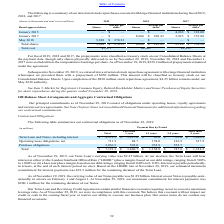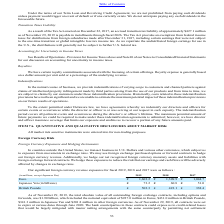According to Adobe Systems's financial document, What is the estimated maximum commitment for interest payments for the remaining duration of the Term Loan based on the LIBOR rate? According to the financial document, $23.2 million. The relevant text states: "mated maximum commitment for interest payments was $23.2 million for the remaining duration of the Term Loan...." Also, can you calculate: What portion of term loan and notes, including interest have payment due more than 5 years? Based on the calculation: 1,016.3/4,373.3 , the result is 23.24 (percentage). This is based on the information: "ding interest $ 4,373.3 $ 3,227.0 $ 65.0 $ 65.0 $ 1,016.3 Term Loan and Notes, including interest $ 4,373.3 $ 3,227.0 $ 65.0 $ 65.0 $ 1,016.3..." The key data points involved are: 1,016.3, 4,373.3. Also, can you calculate: What proportion of operating lease obligations (net) consists of payment obligations that due in less than a year? Based on the calculation: 88.7/711.5, the result is 0.12. This is based on the information: "Operating lease obligations, net 711.5 88.7 158.0 126.9 337.9 Operating lease obligations, net 711.5 88.7 158.0 126.9 337.9..." The key data points involved are: 711.5, 88.7. Also, What is the carrying value of Notes payable as of November 29 2019? According to the financial document, $1.89 (in billions). The relevant text states: "2019, the carrying value of our Notes payable was $1.89 billion. Interest on our Notes is payable semi-..." Also, How often is payment for interest on Notes made? Based on the financial document, the answer is semi-annually. Also, can you calculate: What is the value of contractual obligations for purchase obligations with payment due period of a maximum of 3 years? Based on the calculation: 545+935.8, the result is 1480.8 (in millions). This is based on the information: "Purchase obligations 2,036.5 545.0 935.8 555.7 — Purchase obligations 2,036.5 545.0 935.8 555.7 —..." The key data points involved are: 545, 935.8. 